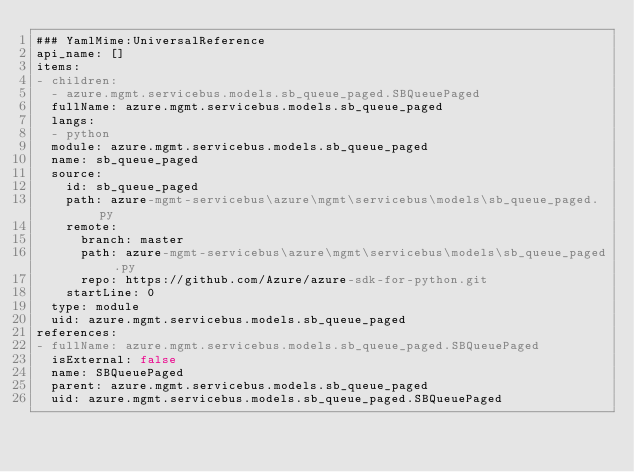Convert code to text. <code><loc_0><loc_0><loc_500><loc_500><_YAML_>### YamlMime:UniversalReference
api_name: []
items:
- children:
  - azure.mgmt.servicebus.models.sb_queue_paged.SBQueuePaged
  fullName: azure.mgmt.servicebus.models.sb_queue_paged
  langs:
  - python
  module: azure.mgmt.servicebus.models.sb_queue_paged
  name: sb_queue_paged
  source:
    id: sb_queue_paged
    path: azure-mgmt-servicebus\azure\mgmt\servicebus\models\sb_queue_paged.py
    remote:
      branch: master
      path: azure-mgmt-servicebus\azure\mgmt\servicebus\models\sb_queue_paged.py
      repo: https://github.com/Azure/azure-sdk-for-python.git
    startLine: 0
  type: module
  uid: azure.mgmt.servicebus.models.sb_queue_paged
references:
- fullName: azure.mgmt.servicebus.models.sb_queue_paged.SBQueuePaged
  isExternal: false
  name: SBQueuePaged
  parent: azure.mgmt.servicebus.models.sb_queue_paged
  uid: azure.mgmt.servicebus.models.sb_queue_paged.SBQueuePaged
</code> 